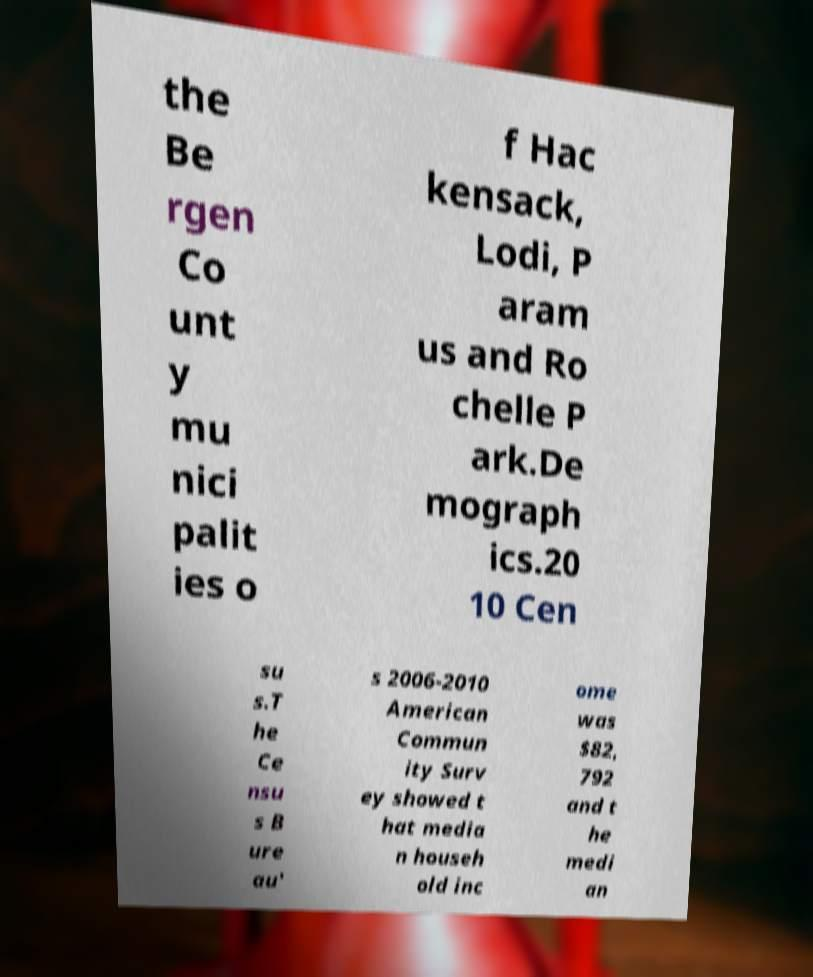Could you assist in decoding the text presented in this image and type it out clearly? the Be rgen Co unt y mu nici palit ies o f Hac kensack, Lodi, P aram us and Ro chelle P ark.De mograph ics.20 10 Cen su s.T he Ce nsu s B ure au' s 2006-2010 American Commun ity Surv ey showed t hat media n househ old inc ome was $82, 792 and t he medi an 